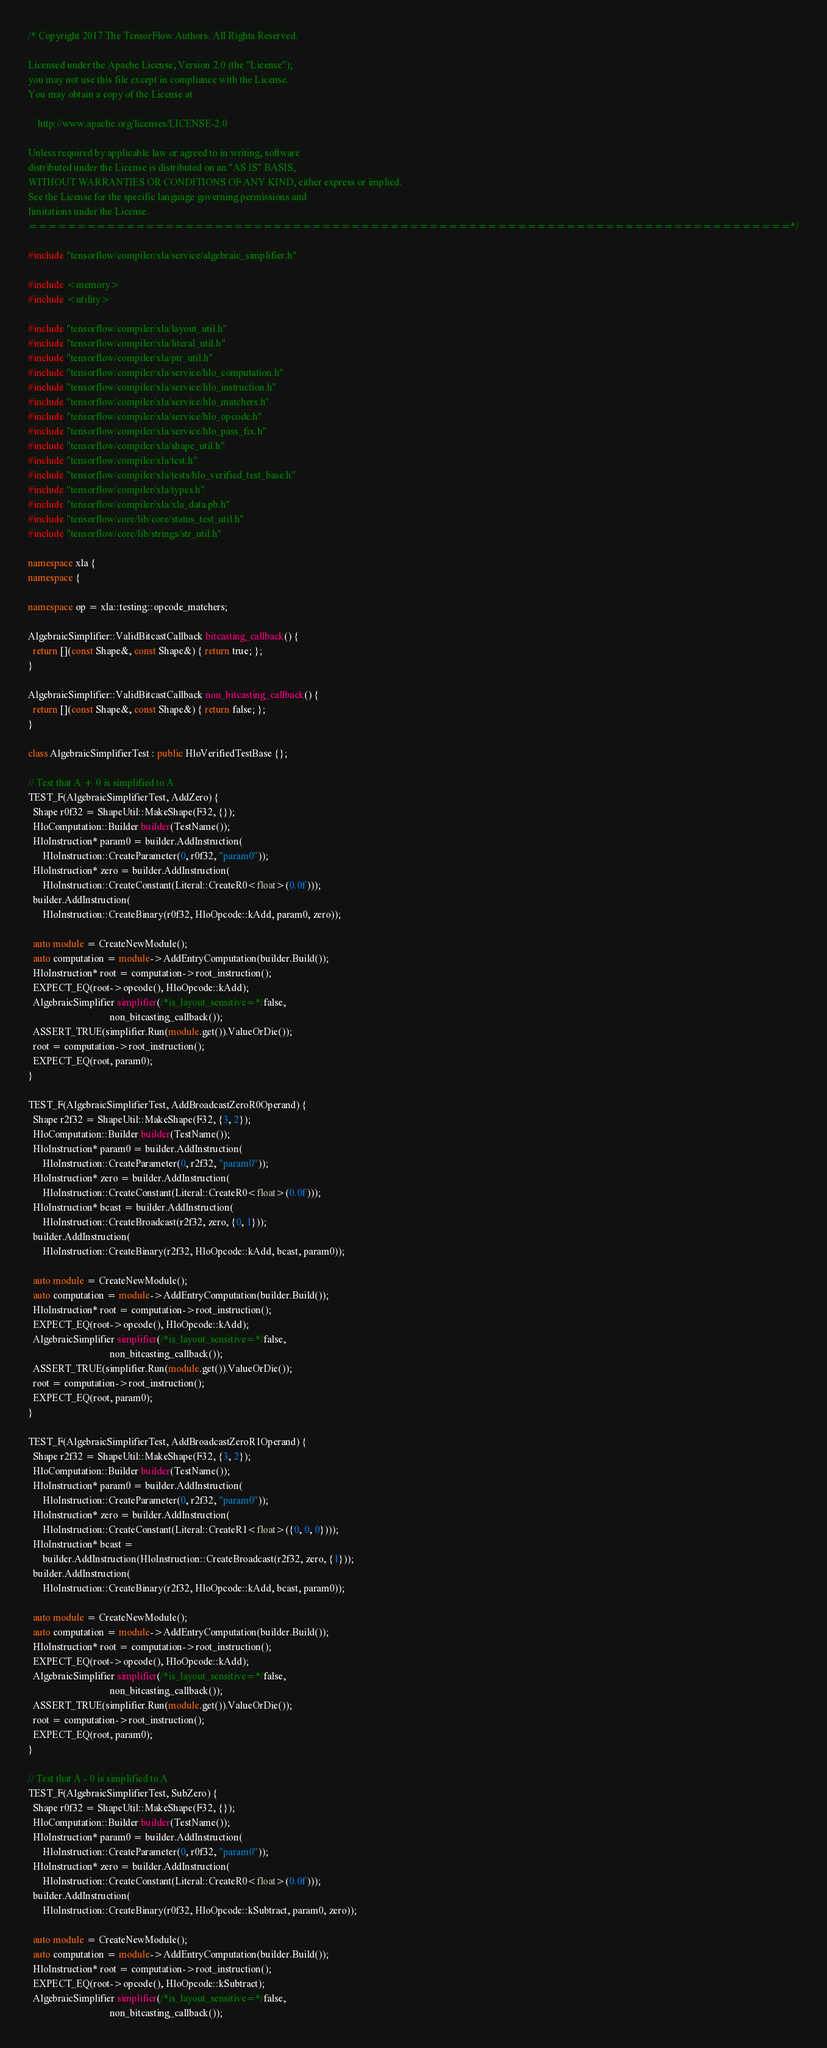Convert code to text. <code><loc_0><loc_0><loc_500><loc_500><_C++_>/* Copyright 2017 The TensorFlow Authors. All Rights Reserved.

Licensed under the Apache License, Version 2.0 (the "License");
you may not use this file except in compliance with the License.
You may obtain a copy of the License at

    http://www.apache.org/licenses/LICENSE-2.0

Unless required by applicable law or agreed to in writing, software
distributed under the License is distributed on an "AS IS" BASIS,
WITHOUT WARRANTIES OR CONDITIONS OF ANY KIND, either express or implied.
See the License for the specific language governing permissions and
limitations under the License.
==============================================================================*/

#include "tensorflow/compiler/xla/service/algebraic_simplifier.h"

#include <memory>
#include <utility>

#include "tensorflow/compiler/xla/layout_util.h"
#include "tensorflow/compiler/xla/literal_util.h"
#include "tensorflow/compiler/xla/ptr_util.h"
#include "tensorflow/compiler/xla/service/hlo_computation.h"
#include "tensorflow/compiler/xla/service/hlo_instruction.h"
#include "tensorflow/compiler/xla/service/hlo_matchers.h"
#include "tensorflow/compiler/xla/service/hlo_opcode.h"
#include "tensorflow/compiler/xla/service/hlo_pass_fix.h"
#include "tensorflow/compiler/xla/shape_util.h"
#include "tensorflow/compiler/xla/test.h"
#include "tensorflow/compiler/xla/tests/hlo_verified_test_base.h"
#include "tensorflow/compiler/xla/types.h"
#include "tensorflow/compiler/xla/xla_data.pb.h"
#include "tensorflow/core/lib/core/status_test_util.h"
#include "tensorflow/core/lib/strings/str_util.h"

namespace xla {
namespace {

namespace op = xla::testing::opcode_matchers;

AlgebraicSimplifier::ValidBitcastCallback bitcasting_callback() {
  return [](const Shape&, const Shape&) { return true; };
}

AlgebraicSimplifier::ValidBitcastCallback non_bitcasting_callback() {
  return [](const Shape&, const Shape&) { return false; };
}

class AlgebraicSimplifierTest : public HloVerifiedTestBase {};

// Test that A + 0 is simplified to A
TEST_F(AlgebraicSimplifierTest, AddZero) {
  Shape r0f32 = ShapeUtil::MakeShape(F32, {});
  HloComputation::Builder builder(TestName());
  HloInstruction* param0 = builder.AddInstruction(
      HloInstruction::CreateParameter(0, r0f32, "param0"));
  HloInstruction* zero = builder.AddInstruction(
      HloInstruction::CreateConstant(Literal::CreateR0<float>(0.0f)));
  builder.AddInstruction(
      HloInstruction::CreateBinary(r0f32, HloOpcode::kAdd, param0, zero));

  auto module = CreateNewModule();
  auto computation = module->AddEntryComputation(builder.Build());
  HloInstruction* root = computation->root_instruction();
  EXPECT_EQ(root->opcode(), HloOpcode::kAdd);
  AlgebraicSimplifier simplifier(/*is_layout_sensitive=*/false,
                                 non_bitcasting_callback());
  ASSERT_TRUE(simplifier.Run(module.get()).ValueOrDie());
  root = computation->root_instruction();
  EXPECT_EQ(root, param0);
}

TEST_F(AlgebraicSimplifierTest, AddBroadcastZeroR0Operand) {
  Shape r2f32 = ShapeUtil::MakeShape(F32, {3, 2});
  HloComputation::Builder builder(TestName());
  HloInstruction* param0 = builder.AddInstruction(
      HloInstruction::CreateParameter(0, r2f32, "param0"));
  HloInstruction* zero = builder.AddInstruction(
      HloInstruction::CreateConstant(Literal::CreateR0<float>(0.0f)));
  HloInstruction* bcast = builder.AddInstruction(
      HloInstruction::CreateBroadcast(r2f32, zero, {0, 1}));
  builder.AddInstruction(
      HloInstruction::CreateBinary(r2f32, HloOpcode::kAdd, bcast, param0));

  auto module = CreateNewModule();
  auto computation = module->AddEntryComputation(builder.Build());
  HloInstruction* root = computation->root_instruction();
  EXPECT_EQ(root->opcode(), HloOpcode::kAdd);
  AlgebraicSimplifier simplifier(/*is_layout_sensitive=*/false,
                                 non_bitcasting_callback());
  ASSERT_TRUE(simplifier.Run(module.get()).ValueOrDie());
  root = computation->root_instruction();
  EXPECT_EQ(root, param0);
}

TEST_F(AlgebraicSimplifierTest, AddBroadcastZeroR1Operand) {
  Shape r2f32 = ShapeUtil::MakeShape(F32, {3, 2});
  HloComputation::Builder builder(TestName());
  HloInstruction* param0 = builder.AddInstruction(
      HloInstruction::CreateParameter(0, r2f32, "param0"));
  HloInstruction* zero = builder.AddInstruction(
      HloInstruction::CreateConstant(Literal::CreateR1<float>({0, 0, 0})));
  HloInstruction* bcast =
      builder.AddInstruction(HloInstruction::CreateBroadcast(r2f32, zero, {1}));
  builder.AddInstruction(
      HloInstruction::CreateBinary(r2f32, HloOpcode::kAdd, bcast, param0));

  auto module = CreateNewModule();
  auto computation = module->AddEntryComputation(builder.Build());
  HloInstruction* root = computation->root_instruction();
  EXPECT_EQ(root->opcode(), HloOpcode::kAdd);
  AlgebraicSimplifier simplifier(/*is_layout_sensitive=*/false,
                                 non_bitcasting_callback());
  ASSERT_TRUE(simplifier.Run(module.get()).ValueOrDie());
  root = computation->root_instruction();
  EXPECT_EQ(root, param0);
}

// Test that A - 0 is simplified to A
TEST_F(AlgebraicSimplifierTest, SubZero) {
  Shape r0f32 = ShapeUtil::MakeShape(F32, {});
  HloComputation::Builder builder(TestName());
  HloInstruction* param0 = builder.AddInstruction(
      HloInstruction::CreateParameter(0, r0f32, "param0"));
  HloInstruction* zero = builder.AddInstruction(
      HloInstruction::CreateConstant(Literal::CreateR0<float>(0.0f)));
  builder.AddInstruction(
      HloInstruction::CreateBinary(r0f32, HloOpcode::kSubtract, param0, zero));

  auto module = CreateNewModule();
  auto computation = module->AddEntryComputation(builder.Build());
  HloInstruction* root = computation->root_instruction();
  EXPECT_EQ(root->opcode(), HloOpcode::kSubtract);
  AlgebraicSimplifier simplifier(/*is_layout_sensitive=*/false,
                                 non_bitcasting_callback());</code> 